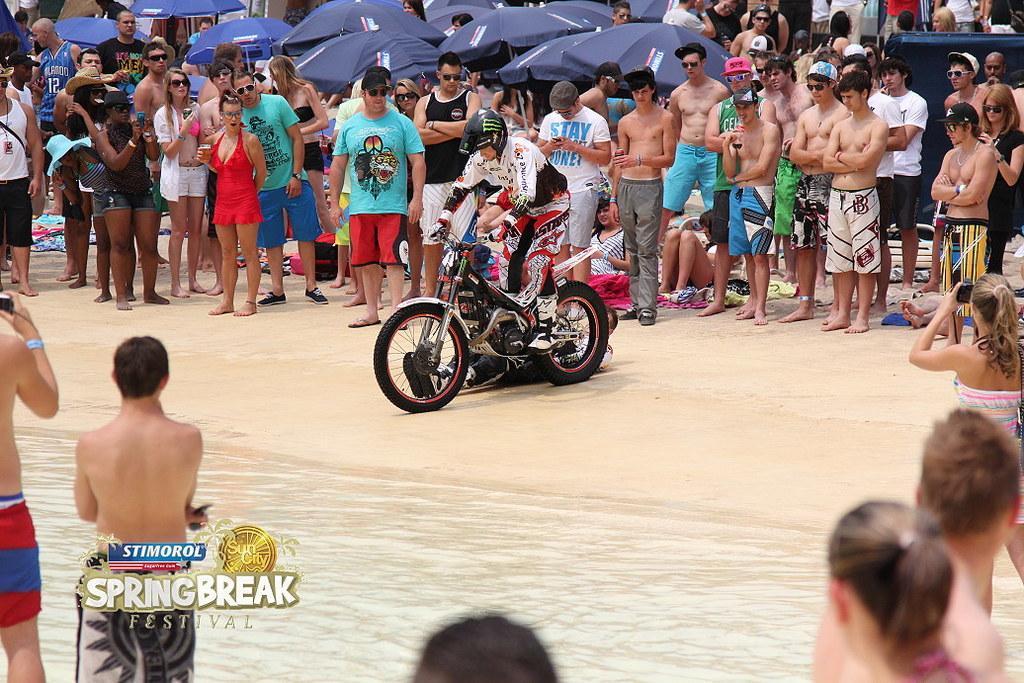Please provide a concise description of this image. This picture shows few people standing and few are standing in the water and we see a man riding a motorcycle and we see a woman holding a camera in her hand and we see few umbrellas on the back and few of them wore caps on their heads and the sunglasses on their faces. 